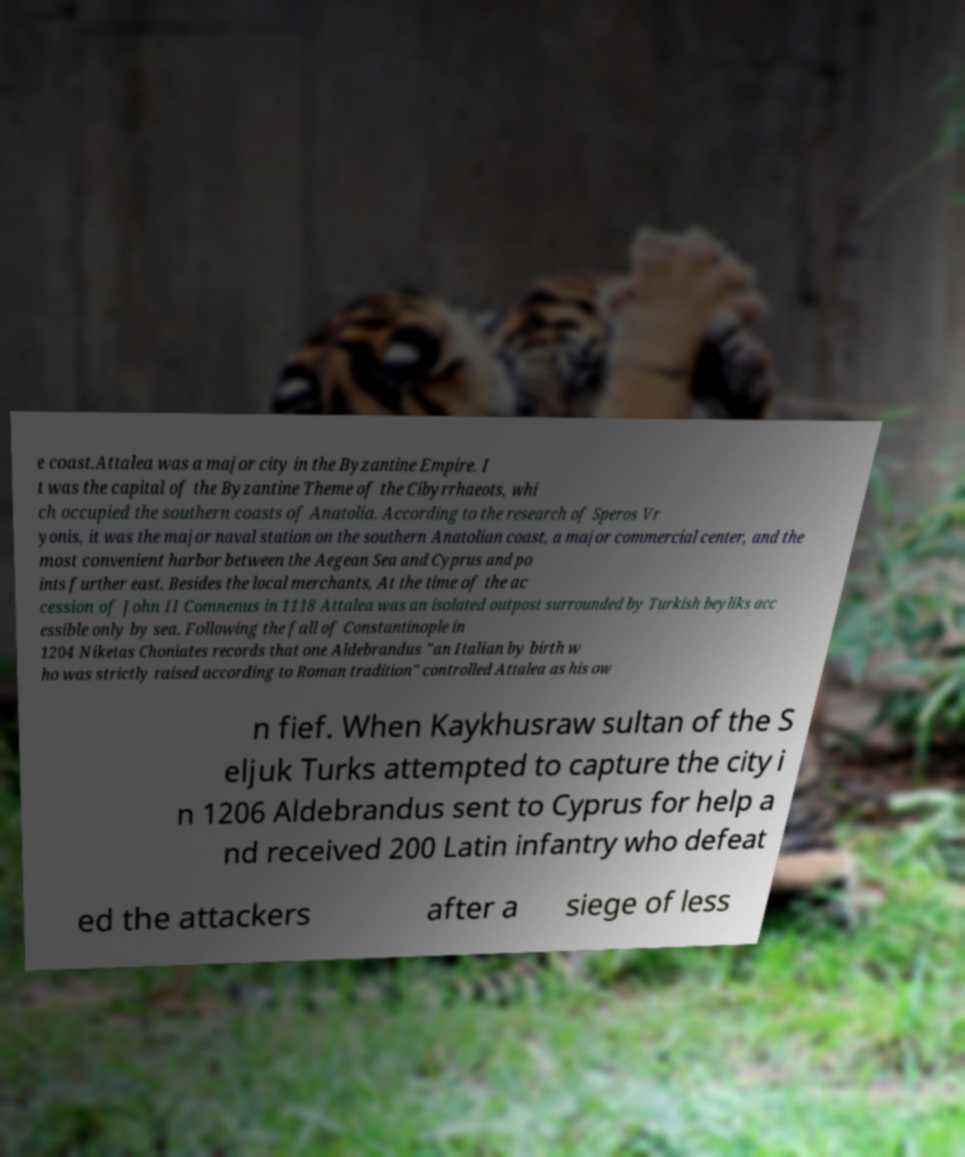Could you extract and type out the text from this image? e coast.Attalea was a major city in the Byzantine Empire. I t was the capital of the Byzantine Theme of the Cibyrrhaeots, whi ch occupied the southern coasts of Anatolia. According to the research of Speros Vr yonis, it was the major naval station on the southern Anatolian coast, a major commercial center, and the most convenient harbor between the Aegean Sea and Cyprus and po ints further east. Besides the local merchants, At the time of the ac cession of John II Comnenus in 1118 Attalea was an isolated outpost surrounded by Turkish beyliks acc essible only by sea. Following the fall of Constantinople in 1204 Niketas Choniates records that one Aldebrandus "an Italian by birth w ho was strictly raised according to Roman tradition" controlled Attalea as his ow n fief. When Kaykhusraw sultan of the S eljuk Turks attempted to capture the city i n 1206 Aldebrandus sent to Cyprus for help a nd received 200 Latin infantry who defeat ed the attackers after a siege of less 